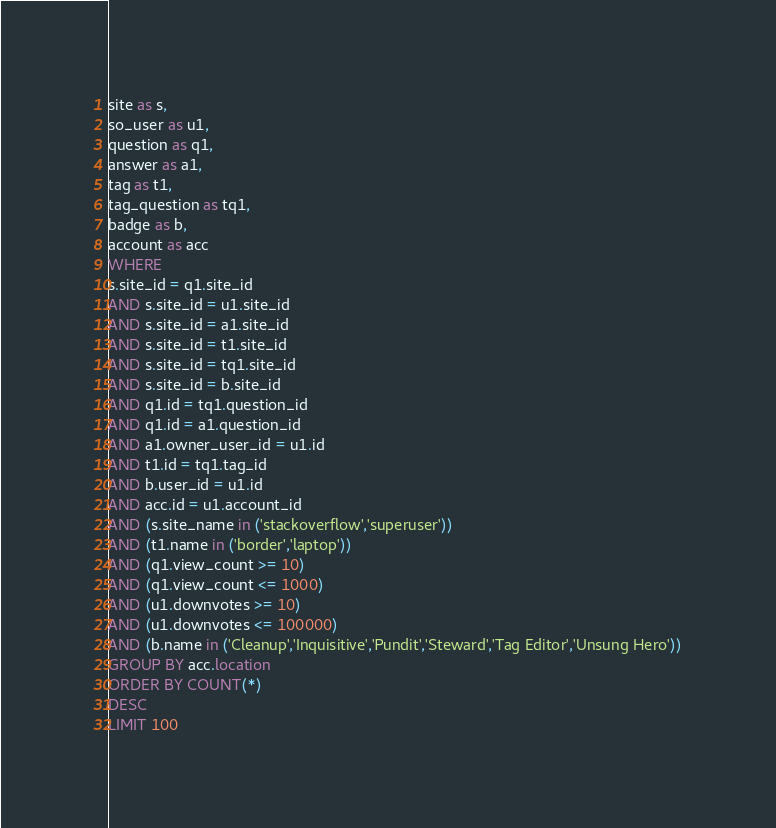Convert code to text. <code><loc_0><loc_0><loc_500><loc_500><_SQL_>site as s,
so_user as u1,
question as q1,
answer as a1,
tag as t1,
tag_question as tq1,
badge as b,
account as acc
WHERE
s.site_id = q1.site_id
AND s.site_id = u1.site_id
AND s.site_id = a1.site_id
AND s.site_id = t1.site_id
AND s.site_id = tq1.site_id
AND s.site_id = b.site_id
AND q1.id = tq1.question_id
AND q1.id = a1.question_id
AND a1.owner_user_id = u1.id
AND t1.id = tq1.tag_id
AND b.user_id = u1.id
AND acc.id = u1.account_id
AND (s.site_name in ('stackoverflow','superuser'))
AND (t1.name in ('border','laptop'))
AND (q1.view_count >= 10)
AND (q1.view_count <= 1000)
AND (u1.downvotes >= 10)
AND (u1.downvotes <= 100000)
AND (b.name in ('Cleanup','Inquisitive','Pundit','Steward','Tag Editor','Unsung Hero'))
GROUP BY acc.location
ORDER BY COUNT(*)
DESC
LIMIT 100
</code> 